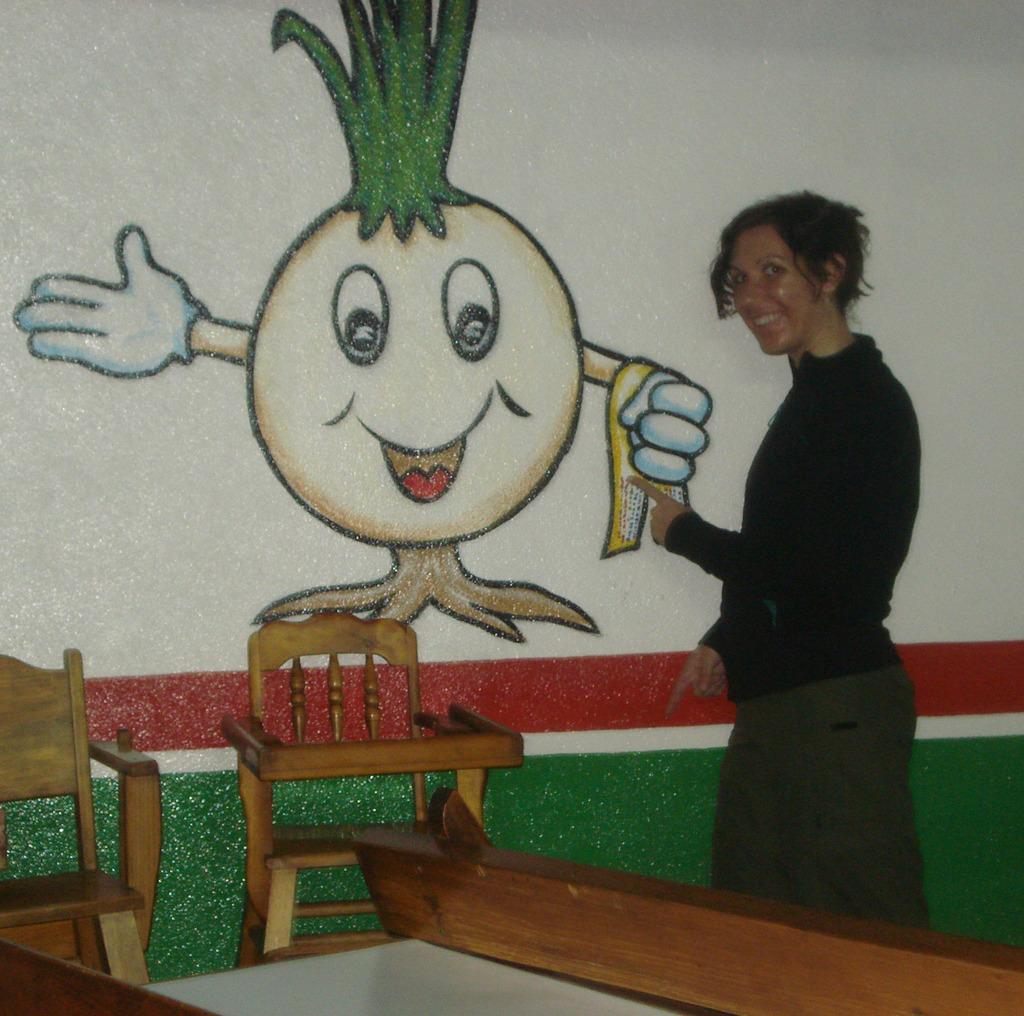Who is present in the image? There is a woman in the image. What is the woman doing in the image? The woman is standing at a wall. What can be seen on the wall in the image? There is a drawing on the wall. What type of fruit is hanging from the wall in the image? There is no fruit hanging from the wall in the image; it features a drawing instead. 